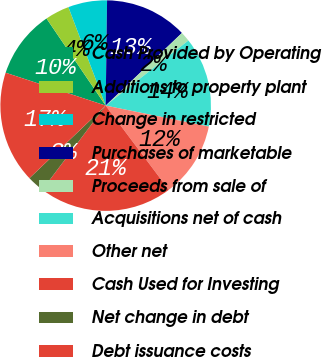<chart> <loc_0><loc_0><loc_500><loc_500><pie_chart><fcel>Cash Provided by Operating<fcel>Additions to property plant<fcel>Change in restricted<fcel>Purchases of marketable<fcel>Proceeds from sale of<fcel>Acquisitions net of cash<fcel>Other net<fcel>Cash Used for Investing<fcel>Net change in debt<fcel>Debt issuance costs<nl><fcel>10.45%<fcel>3.74%<fcel>5.97%<fcel>12.68%<fcel>1.5%<fcel>13.8%<fcel>11.57%<fcel>20.51%<fcel>2.62%<fcel>17.16%<nl></chart> 